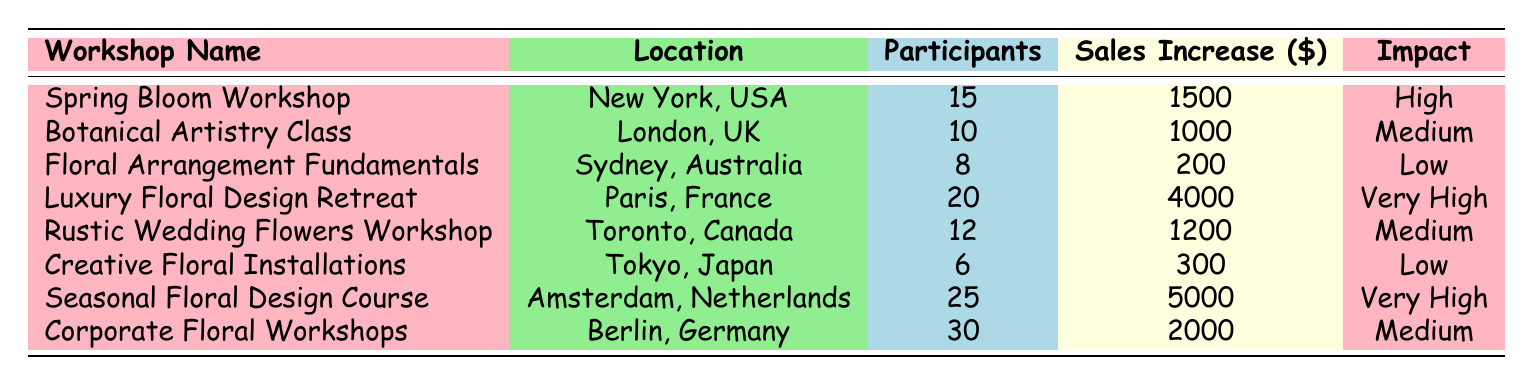What is the sales increase from the Luxury Floral Design Retreat? The table lists the sales increase for the Luxury Floral Design Retreat as $4000.
Answer: $4000 Which workshop had the highest sales increase? By comparing the sales increase values, the Seasonal Floral Design Course had the highest increase of $5000.
Answer: Seasonal Floral Design Course How many participants were there in total across all workshops? Adding the number of participants from each workshop: 15 + 10 + 8 + 20 + 12 + 6 + 25 + 30 = 126 participants in total.
Answer: 126 Did the Creative Floral Installations workshop have a high impact? The impact of the Creative Floral Installations workshop is labeled as "Low" in the table, so it did not have a high impact.
Answer: No What is the average sales increase of workshops categorized as "Medium"? The total sales increase for Medium impact workshops (Botanical Artistry Class: $1000, Rustic Wedding Flowers Workshop: $1200, Corporate Floral Workshops: $2000) is $1000 + $1200 + $2000 = $4200; dividing this by 3 gives an average of $1400.
Answer: $1400 How many workshops had an impact rating of "Very High"? The table shows two workshops, Luxury Floral Design Retreat and Seasonal Floral Design Course, which are categorized as "Very High" in impact.
Answer: 2 What is the difference in participants between the workshop with the most participants and the one with the least? The workshop with the most participants is Corporate Floral Workshops (30 participants) and the one with the least is Creative Floral Installations (6 participants); their difference is 30 - 6 = 24 participants.
Answer: 24 Is the sales increase for the Spring Bloom Workshop higher than the sales increase for the Floral Arrangement Fundamentals? The sales increase for the Spring Bloom Workshop is $1500, and for Floral Arrangement Fundamentals, it is $200. Therefore, $1500 is greater than $200.
Answer: Yes 